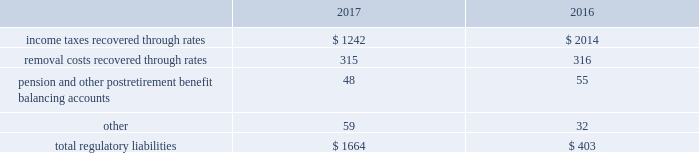Regulatory balancing accounts accumulate differences between revenues recognized and authorized revenue requirements until they are collected from customers or are refunded .
Regulatory balancing accounts include low income programs and purchased power and water accounts .
Debt expense is amortized over the lives of the respective issues .
Call premiums on the redemption of long- term debt , as well as unamortized debt expense , are deferred and amortized to the extent they will be recovered through future service rates .
As a result of american water capital corp . 2019s prepayment of the 5.62% ( 5.62 % ) series c senior notes due december 21 , 2018 ( 201cseries c senior notes 201d ) and 5.77% ( 5.77 % ) series d senior notes due december 21 , 2021 ( 201cseries d senior notes 201d ) and payment of a make-whole premium amount to the holders thereof of $ 34 million , the company recorded a $ 6 million charge resulting from the early extinguishment of debt at the parent company .
Substantially all of the early debt extinguishment costs allocable to the company 2019s utility subsidiaries were recorded as regulatory assets that the company believes are probable of recovery in future rates .
Approximately $ 1 million of the early debt extinguishment costs allocable to the company 2019s utility subsidiaries was amortized in 2017 .
Purchase premium recoverable through rates is primarily the recovery of the acquisition premiums related to an asset acquisition by the company 2019s california utility subsidiary during 2002 , and acquisitions in 2007 by the company 2019s new jersey utility subsidiary .
As authorized for recovery by the california and new jersey pucs , these costs are being amortized to depreciation and amortization in the consolidated statements of operations through november 2048 .
Tank painting costs are generally deferred and amortized to operations and maintenance expense in the consolidated statements of operations on a straight-line basis over periods ranging from two to fifteen years , as authorized by the regulatory authorities in their determination of rates charged for service .
Other regulatory assets include certain construction costs for treatment facilities , property tax stabilization , employee-related costs , deferred other postretirement benefit expense , business services project expenses , coastal water project costs , rate case expenditures and environmental remediation costs among others .
These costs are deferred because the amounts are being recovered in rates or are probable of recovery through rates in future periods .
Regulatory liabilities regulatory liabilities generally represent amounts that are probable of being credited or refunded to customers through the rate-making process .
Also , if costs expected to be incurred in the future are currently being recovered through rates , the company records those expected future costs as regulatory liabilities .
The table summarizes the composition of regulatory liabilities as of december 31: .
Income taxes recovered through rates relate to deferred taxes that will likely be refunded to the company 2019s customers .
On december 22 , 2017 , the tcja was signed into law , which , among other things , enacted significant and complex changes to the internal revenue code of 1986 , including a reduction in the maximum u.s .
Federal corporate income tax rate from 35% ( 35 % ) to 21% ( 21 % ) as of january 1 , 2018 .
The tcja created significant .
What percentage of total regulatory liabilities consisted of income taxes recovered through rates in 2017? 
Computations: (1242 / 1664)
Answer: 0.74639. Regulatory balancing accounts accumulate differences between revenues recognized and authorized revenue requirements until they are collected from customers or are refunded .
Regulatory balancing accounts include low income programs and purchased power and water accounts .
Debt expense is amortized over the lives of the respective issues .
Call premiums on the redemption of long- term debt , as well as unamortized debt expense , are deferred and amortized to the extent they will be recovered through future service rates .
As a result of american water capital corp . 2019s prepayment of the 5.62% ( 5.62 % ) series c senior notes due december 21 , 2018 ( 201cseries c senior notes 201d ) and 5.77% ( 5.77 % ) series d senior notes due december 21 , 2021 ( 201cseries d senior notes 201d ) and payment of a make-whole premium amount to the holders thereof of $ 34 million , the company recorded a $ 6 million charge resulting from the early extinguishment of debt at the parent company .
Substantially all of the early debt extinguishment costs allocable to the company 2019s utility subsidiaries were recorded as regulatory assets that the company believes are probable of recovery in future rates .
Approximately $ 1 million of the early debt extinguishment costs allocable to the company 2019s utility subsidiaries was amortized in 2017 .
Purchase premium recoverable through rates is primarily the recovery of the acquisition premiums related to an asset acquisition by the company 2019s california utility subsidiary during 2002 , and acquisitions in 2007 by the company 2019s new jersey utility subsidiary .
As authorized for recovery by the california and new jersey pucs , these costs are being amortized to depreciation and amortization in the consolidated statements of operations through november 2048 .
Tank painting costs are generally deferred and amortized to operations and maintenance expense in the consolidated statements of operations on a straight-line basis over periods ranging from two to fifteen years , as authorized by the regulatory authorities in their determination of rates charged for service .
Other regulatory assets include certain construction costs for treatment facilities , property tax stabilization , employee-related costs , deferred other postretirement benefit expense , business services project expenses , coastal water project costs , rate case expenditures and environmental remediation costs among others .
These costs are deferred because the amounts are being recovered in rates or are probable of recovery through rates in future periods .
Regulatory liabilities regulatory liabilities generally represent amounts that are probable of being credited or refunded to customers through the rate-making process .
Also , if costs expected to be incurred in the future are currently being recovered through rates , the company records those expected future costs as regulatory liabilities .
The table summarizes the composition of regulatory liabilities as of december 31: .
Income taxes recovered through rates relate to deferred taxes that will likely be refunded to the company 2019s customers .
On december 22 , 2017 , the tcja was signed into law , which , among other things , enacted significant and complex changes to the internal revenue code of 1986 , including a reduction in the maximum u.s .
Federal corporate income tax rate from 35% ( 35 % ) to 21% ( 21 % ) as of january 1 , 2018 .
The tcja created significant .
As a result of the addition of income taxes recovered through rates , how much did total regulatory liabilities increase from 2016 to 2017? 
Computations: ((1664 - 403) / 403)
Answer: 3.12903. Regulatory balancing accounts accumulate differences between revenues recognized and authorized revenue requirements until they are collected from customers or are refunded .
Regulatory balancing accounts include low income programs and purchased power and water accounts .
Debt expense is amortized over the lives of the respective issues .
Call premiums on the redemption of long- term debt , as well as unamortized debt expense , are deferred and amortized to the extent they will be recovered through future service rates .
As a result of american water capital corp . 2019s prepayment of the 5.62% ( 5.62 % ) series c senior notes due december 21 , 2018 ( 201cseries c senior notes 201d ) and 5.77% ( 5.77 % ) series d senior notes due december 21 , 2021 ( 201cseries d senior notes 201d ) and payment of a make-whole premium amount to the holders thereof of $ 34 million , the company recorded a $ 6 million charge resulting from the early extinguishment of debt at the parent company .
Substantially all of the early debt extinguishment costs allocable to the company 2019s utility subsidiaries were recorded as regulatory assets that the company believes are probable of recovery in future rates .
Approximately $ 1 million of the early debt extinguishment costs allocable to the company 2019s utility subsidiaries was amortized in 2017 .
Purchase premium recoverable through rates is primarily the recovery of the acquisition premiums related to an asset acquisition by the company 2019s california utility subsidiary during 2002 , and acquisitions in 2007 by the company 2019s new jersey utility subsidiary .
As authorized for recovery by the california and new jersey pucs , these costs are being amortized to depreciation and amortization in the consolidated statements of operations through november 2048 .
Tank painting costs are generally deferred and amortized to operations and maintenance expense in the consolidated statements of operations on a straight-line basis over periods ranging from two to fifteen years , as authorized by the regulatory authorities in their determination of rates charged for service .
Other regulatory assets include certain construction costs for treatment facilities , property tax stabilization , employee-related costs , deferred other postretirement benefit expense , business services project expenses , coastal water project costs , rate case expenditures and environmental remediation costs among others .
These costs are deferred because the amounts are being recovered in rates or are probable of recovery through rates in future periods .
Regulatory liabilities regulatory liabilities generally represent amounts that are probable of being credited or refunded to customers through the rate-making process .
Also , if costs expected to be incurred in the future are currently being recovered through rates , the company records those expected future costs as regulatory liabilities .
The table summarizes the composition of regulatory liabilities as of december 31: .
Income taxes recovered through rates relate to deferred taxes that will likely be refunded to the company 2019s customers .
On december 22 , 2017 , the tcja was signed into law , which , among other things , enacted significant and complex changes to the internal revenue code of 1986 , including a reduction in the maximum u.s .
Federal corporate income tax rate from 35% ( 35 % ) to 21% ( 21 % ) as of january 1 , 2018 .
The tcja created significant .
In 2017 what was the ratio of the removal costs to the total regulatory costs? 
Rationale: for every dollar in removal costs there was 5.3 dollars in regulatory costs .
Computations: (1664 / 315)
Answer: 5.28254. Regulatory balancing accounts accumulate differences between revenues recognized and authorized revenue requirements until they are collected from customers or are refunded .
Regulatory balancing accounts include low income programs and purchased power and water accounts .
Debt expense is amortized over the lives of the respective issues .
Call premiums on the redemption of long- term debt , as well as unamortized debt expense , are deferred and amortized to the extent they will be recovered through future service rates .
As a result of american water capital corp . 2019s prepayment of the 5.62% ( 5.62 % ) series c senior notes due december 21 , 2018 ( 201cseries c senior notes 201d ) and 5.77% ( 5.77 % ) series d senior notes due december 21 , 2021 ( 201cseries d senior notes 201d ) and payment of a make-whole premium amount to the holders thereof of $ 34 million , the company recorded a $ 6 million charge resulting from the early extinguishment of debt at the parent company .
Substantially all of the early debt extinguishment costs allocable to the company 2019s utility subsidiaries were recorded as regulatory assets that the company believes are probable of recovery in future rates .
Approximately $ 1 million of the early debt extinguishment costs allocable to the company 2019s utility subsidiaries was amortized in 2017 .
Purchase premium recoverable through rates is primarily the recovery of the acquisition premiums related to an asset acquisition by the company 2019s california utility subsidiary during 2002 , and acquisitions in 2007 by the company 2019s new jersey utility subsidiary .
As authorized for recovery by the california and new jersey pucs , these costs are being amortized to depreciation and amortization in the consolidated statements of operations through november 2048 .
Tank painting costs are generally deferred and amortized to operations and maintenance expense in the consolidated statements of operations on a straight-line basis over periods ranging from two to fifteen years , as authorized by the regulatory authorities in their determination of rates charged for service .
Other regulatory assets include certain construction costs for treatment facilities , property tax stabilization , employee-related costs , deferred other postretirement benefit expense , business services project expenses , coastal water project costs , rate case expenditures and environmental remediation costs among others .
These costs are deferred because the amounts are being recovered in rates or are probable of recovery through rates in future periods .
Regulatory liabilities regulatory liabilities generally represent amounts that are probable of being credited or refunded to customers through the rate-making process .
Also , if costs expected to be incurred in the future are currently being recovered through rates , the company records those expected future costs as regulatory liabilities .
The table summarizes the composition of regulatory liabilities as of december 31: .
Income taxes recovered through rates relate to deferred taxes that will likely be refunded to the company 2019s customers .
On december 22 , 2017 , the tcja was signed into law , which , among other things , enacted significant and complex changes to the internal revenue code of 1986 , including a reduction in the maximum u.s .
Federal corporate income tax rate from 35% ( 35 % ) to 21% ( 21 % ) as of january 1 , 2018 .
The tcja created significant .
What was the growth rate of the regulatory liability from 2016 to 2017? 
Rationale: the growth rate is the change from period to period divide by the begin balance
Computations: ((1664 - 403) / 403)
Answer: 3.12903. 